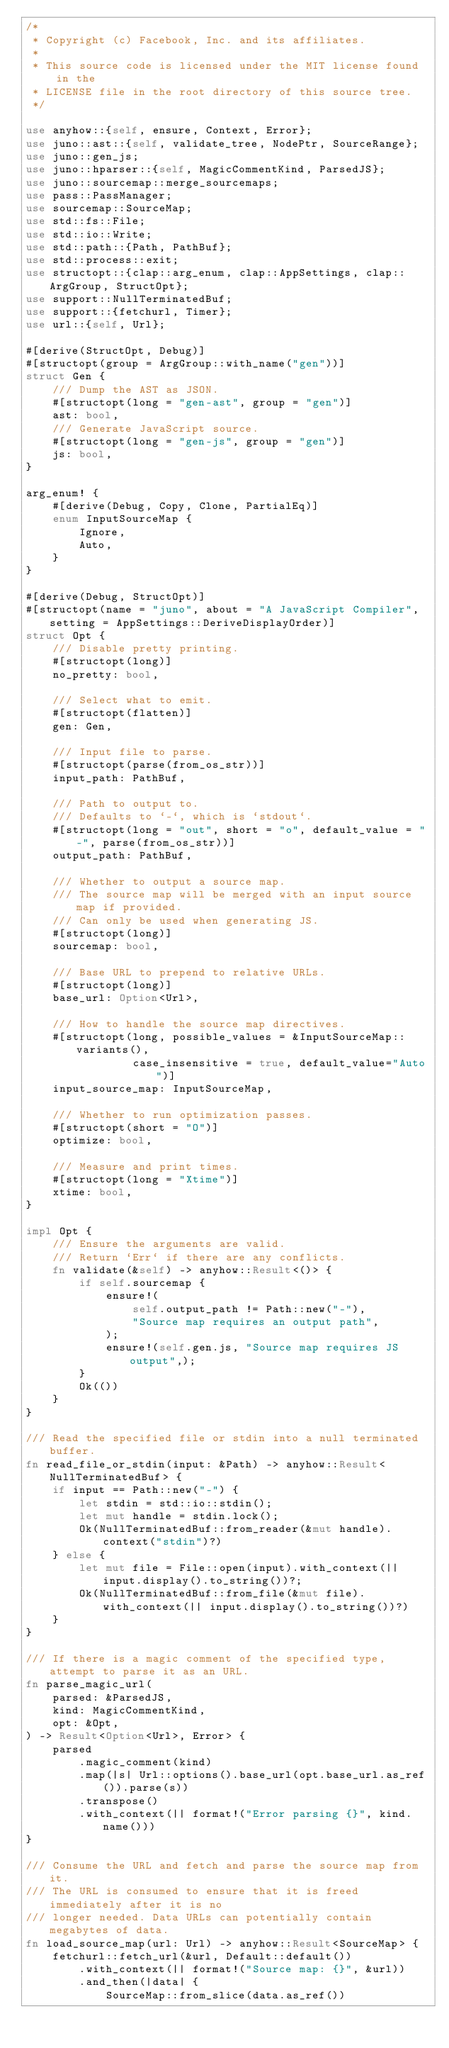Convert code to text. <code><loc_0><loc_0><loc_500><loc_500><_Rust_>/*
 * Copyright (c) Facebook, Inc. and its affiliates.
 *
 * This source code is licensed under the MIT license found in the
 * LICENSE file in the root directory of this source tree.
 */

use anyhow::{self, ensure, Context, Error};
use juno::ast::{self, validate_tree, NodePtr, SourceRange};
use juno::gen_js;
use juno::hparser::{self, MagicCommentKind, ParsedJS};
use juno::sourcemap::merge_sourcemaps;
use pass::PassManager;
use sourcemap::SourceMap;
use std::fs::File;
use std::io::Write;
use std::path::{Path, PathBuf};
use std::process::exit;
use structopt::{clap::arg_enum, clap::AppSettings, clap::ArgGroup, StructOpt};
use support::NullTerminatedBuf;
use support::{fetchurl, Timer};
use url::{self, Url};

#[derive(StructOpt, Debug)]
#[structopt(group = ArgGroup::with_name("gen"))]
struct Gen {
    /// Dump the AST as JSON.
    #[structopt(long = "gen-ast", group = "gen")]
    ast: bool,
    /// Generate JavaScript source.
    #[structopt(long = "gen-js", group = "gen")]
    js: bool,
}

arg_enum! {
    #[derive(Debug, Copy, Clone, PartialEq)]
    enum InputSourceMap {
        Ignore,
        Auto,
    }
}

#[derive(Debug, StructOpt)]
#[structopt(name = "juno", about = "A JavaScript Compiler", setting = AppSettings::DeriveDisplayOrder)]
struct Opt {
    /// Disable pretty printing.
    #[structopt(long)]
    no_pretty: bool,

    /// Select what to emit.
    #[structopt(flatten)]
    gen: Gen,

    /// Input file to parse.
    #[structopt(parse(from_os_str))]
    input_path: PathBuf,

    /// Path to output to.
    /// Defaults to `-`, which is `stdout`.
    #[structopt(long = "out", short = "o", default_value = "-", parse(from_os_str))]
    output_path: PathBuf,

    /// Whether to output a source map.
    /// The source map will be merged with an input source map if provided.
    /// Can only be used when generating JS.
    #[structopt(long)]
    sourcemap: bool,

    /// Base URL to prepend to relative URLs.
    #[structopt(long)]
    base_url: Option<Url>,

    /// How to handle the source map directives.
    #[structopt(long, possible_values = &InputSourceMap::variants(),
                case_insensitive = true, default_value="Auto")]
    input_source_map: InputSourceMap,

    /// Whether to run optimization passes.
    #[structopt(short = "O")]
    optimize: bool,

    /// Measure and print times.
    #[structopt(long = "Xtime")]
    xtime: bool,
}

impl Opt {
    /// Ensure the arguments are valid.
    /// Return `Err` if there are any conflicts.
    fn validate(&self) -> anyhow::Result<()> {
        if self.sourcemap {
            ensure!(
                self.output_path != Path::new("-"),
                "Source map requires an output path",
            );
            ensure!(self.gen.js, "Source map requires JS output",);
        }
        Ok(())
    }
}

/// Read the specified file or stdin into a null terminated buffer.
fn read_file_or_stdin(input: &Path) -> anyhow::Result<NullTerminatedBuf> {
    if input == Path::new("-") {
        let stdin = std::io::stdin();
        let mut handle = stdin.lock();
        Ok(NullTerminatedBuf::from_reader(&mut handle).context("stdin")?)
    } else {
        let mut file = File::open(input).with_context(|| input.display().to_string())?;
        Ok(NullTerminatedBuf::from_file(&mut file).with_context(|| input.display().to_string())?)
    }
}

/// If there is a magic comment of the specified type, attempt to parse it as an URL.
fn parse_magic_url(
    parsed: &ParsedJS,
    kind: MagicCommentKind,
    opt: &Opt,
) -> Result<Option<Url>, Error> {
    parsed
        .magic_comment(kind)
        .map(|s| Url::options().base_url(opt.base_url.as_ref()).parse(s))
        .transpose()
        .with_context(|| format!("Error parsing {}", kind.name()))
}

/// Consume the URL and fetch and parse the source map from it.
/// The URL is consumed to ensure that it is freed immediately after it is no
/// longer needed. Data URLs can potentially contain megabytes of data.
fn load_source_map(url: Url) -> anyhow::Result<SourceMap> {
    fetchurl::fetch_url(&url, Default::default())
        .with_context(|| format!("Source map: {}", &url))
        .and_then(|data| {
            SourceMap::from_slice(data.as_ref())</code> 